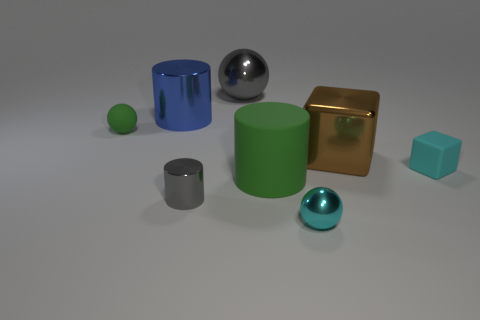Is the material of the tiny sphere that is to the left of the large green cylinder the same as the ball that is right of the large gray object?
Offer a terse response. No. What number of tiny blocks are in front of the small metallic sphere?
Give a very brief answer. 0. What number of cyan objects are either tiny cylinders or large shiny balls?
Provide a short and direct response. 0. There is a green sphere that is the same size as the gray cylinder; what is its material?
Give a very brief answer. Rubber. The big thing that is behind the cyan block and in front of the matte ball has what shape?
Your response must be concise. Cube. What color is the shiny ball that is the same size as the green matte cylinder?
Ensure brevity in your answer.  Gray. Does the metallic cylinder that is in front of the green rubber ball have the same size as the metal sphere to the right of the gray ball?
Give a very brief answer. Yes. There is a green matte thing on the right side of the small object that is to the left of the cylinder that is to the left of the small cylinder; what size is it?
Provide a short and direct response. Large. There is a matte thing to the left of the large gray metal object left of the green rubber cylinder; what shape is it?
Offer a terse response. Sphere. There is a tiny rubber object that is to the right of the cyan shiny sphere; is its color the same as the matte sphere?
Your response must be concise. No. 